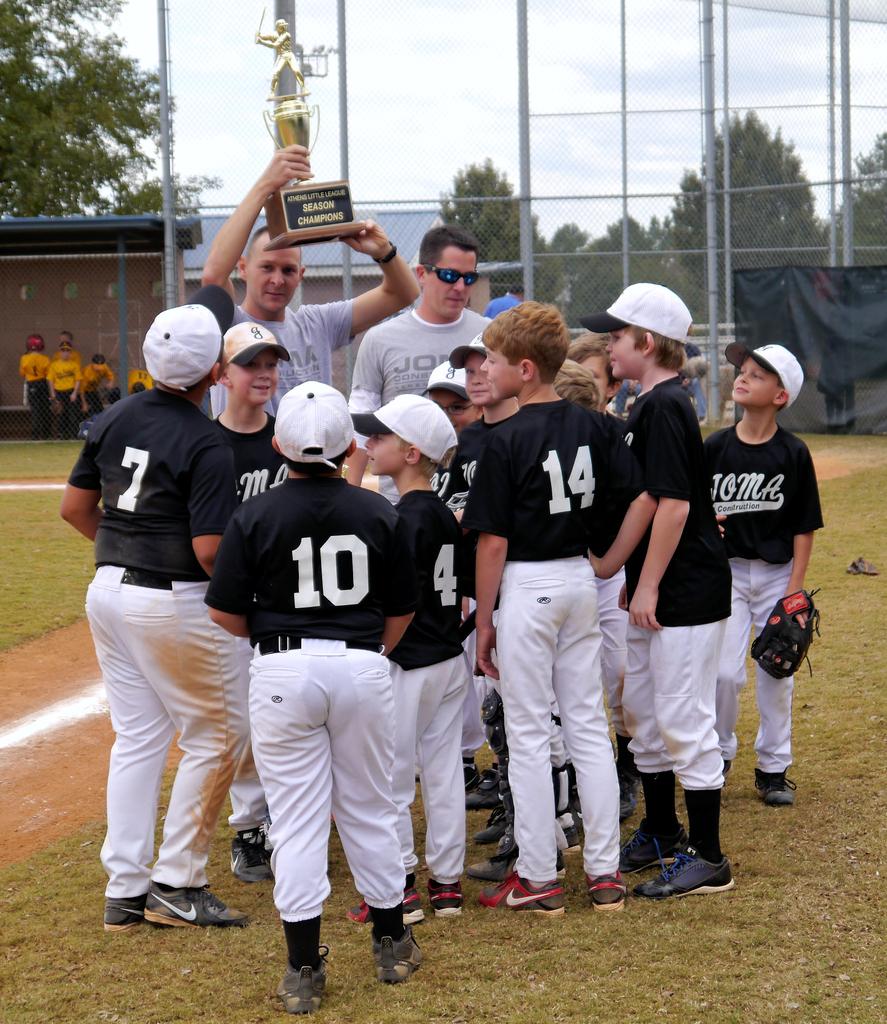What trophy did they win?
Offer a very short reply. Season champions. What is the jersey number of the player on the far left?
Give a very brief answer. 7. 